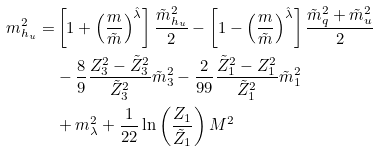<formula> <loc_0><loc_0><loc_500><loc_500>m _ { h _ { u } } ^ { 2 } = & \left [ 1 + \left ( \frac { m } { \tilde { m } } \right ) ^ { \hat { \lambda } } \right ] \frac { \tilde { m } _ { h _ { u } } ^ { 2 } } { 2 } - \left [ 1 - \left ( \frac { m } { \tilde { m } } \right ) ^ { \hat { \lambda } } \right ] \frac { \tilde { m } _ { q } ^ { 2 } + \tilde { m } _ { u } ^ { 2 } } { 2 } \\ & - \frac { 8 } { 9 } \frac { Z _ { 3 } ^ { 2 } - \tilde { Z } _ { 3 } ^ { 2 } } { \tilde { Z } _ { 3 } ^ { 2 } } \tilde { m } _ { 3 } ^ { 2 } - \frac { 2 } { 9 9 } \frac { \tilde { Z } _ { 1 } ^ { 2 } - Z _ { 1 } ^ { 2 } } { \tilde { Z } _ { 1 } ^ { 2 } } \tilde { m } _ { 1 } ^ { 2 } \\ & + m _ { \lambda } ^ { 2 } + \frac { 1 } { 2 2 } \ln \left ( \frac { Z _ { 1 } } { \tilde { Z } _ { 1 } } \right ) M ^ { 2 }</formula> 